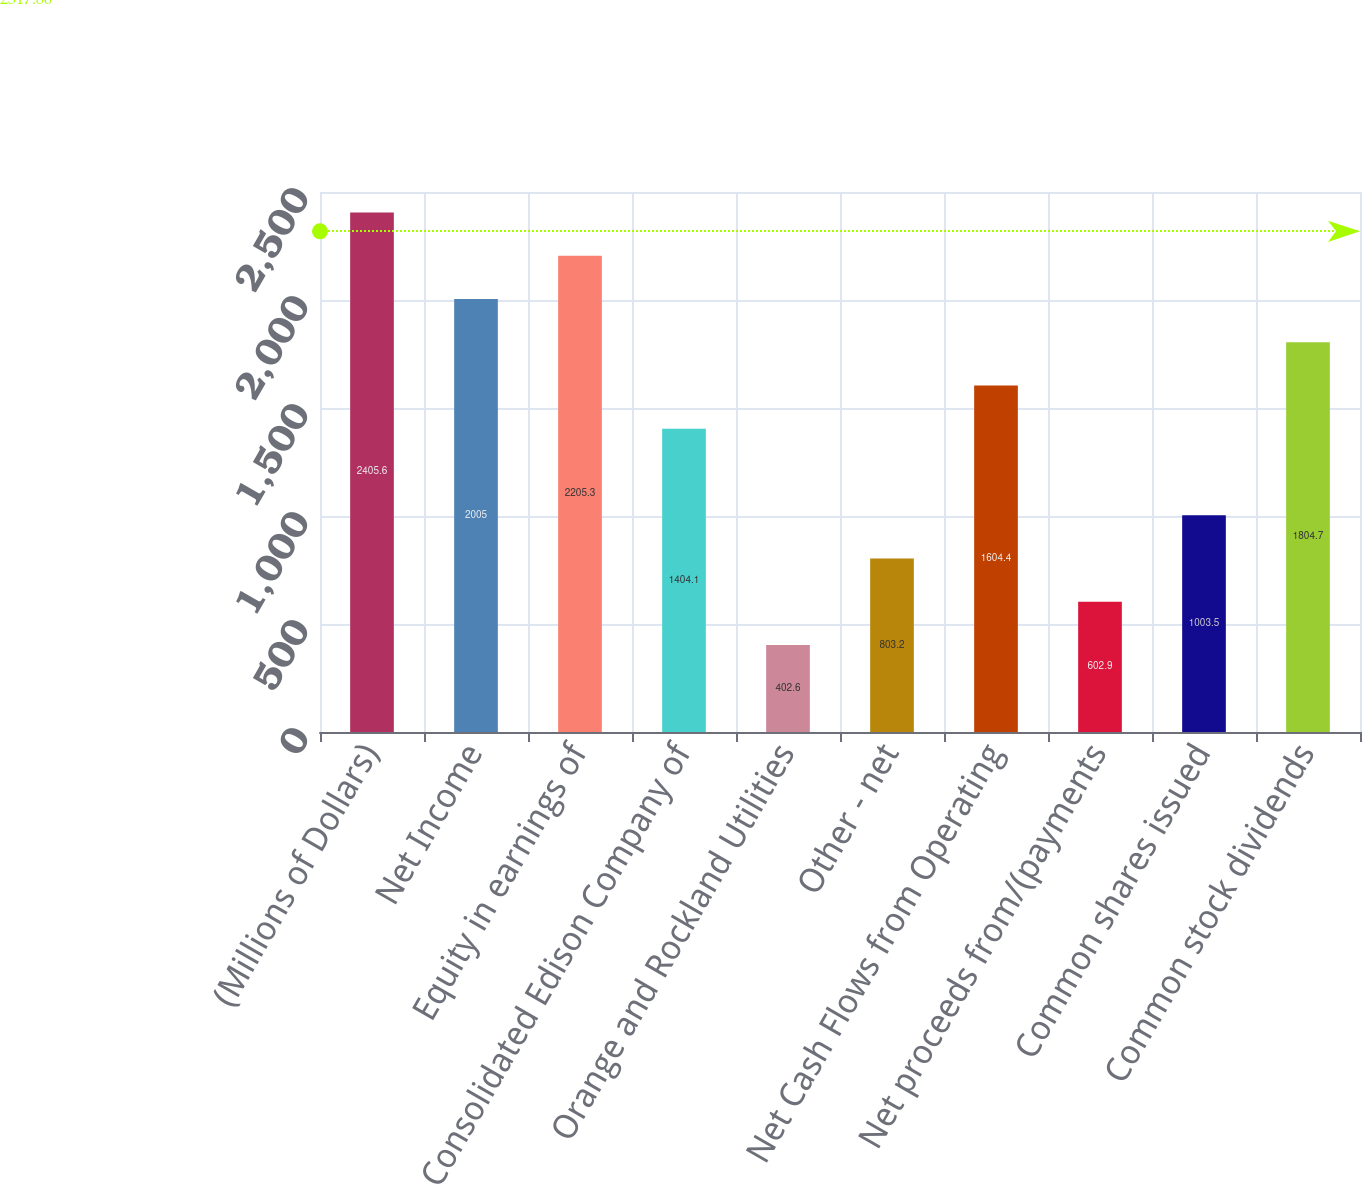<chart> <loc_0><loc_0><loc_500><loc_500><bar_chart><fcel>(Millions of Dollars)<fcel>Net Income<fcel>Equity in earnings of<fcel>Consolidated Edison Company of<fcel>Orange and Rockland Utilities<fcel>Other - net<fcel>Net Cash Flows from Operating<fcel>Net proceeds from/(payments<fcel>Common shares issued<fcel>Common stock dividends<nl><fcel>2405.6<fcel>2005<fcel>2205.3<fcel>1404.1<fcel>402.6<fcel>803.2<fcel>1604.4<fcel>602.9<fcel>1003.5<fcel>1804.7<nl></chart> 